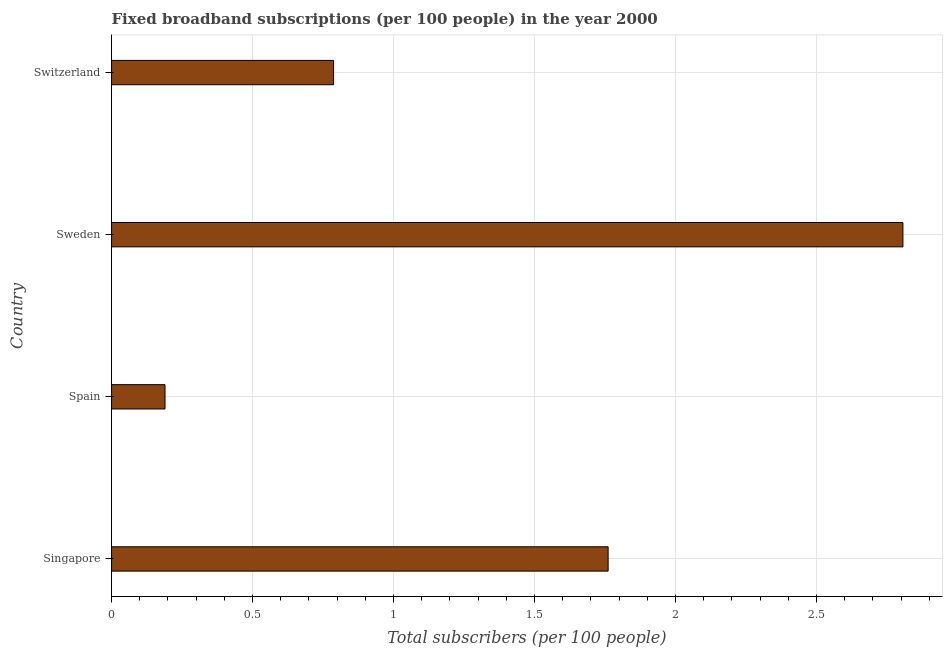What is the title of the graph?
Your response must be concise. Fixed broadband subscriptions (per 100 people) in the year 2000. What is the label or title of the X-axis?
Offer a very short reply. Total subscribers (per 100 people). What is the total number of fixed broadband subscriptions in Switzerland?
Your response must be concise. 0.79. Across all countries, what is the maximum total number of fixed broadband subscriptions?
Provide a succinct answer. 2.81. Across all countries, what is the minimum total number of fixed broadband subscriptions?
Your response must be concise. 0.19. What is the sum of the total number of fixed broadband subscriptions?
Ensure brevity in your answer.  5.54. What is the difference between the total number of fixed broadband subscriptions in Sweden and Switzerland?
Provide a succinct answer. 2.02. What is the average total number of fixed broadband subscriptions per country?
Make the answer very short. 1.39. What is the median total number of fixed broadband subscriptions?
Your response must be concise. 1.27. What is the ratio of the total number of fixed broadband subscriptions in Singapore to that in Switzerland?
Your answer should be very brief. 2.24. Is the difference between the total number of fixed broadband subscriptions in Sweden and Switzerland greater than the difference between any two countries?
Give a very brief answer. No. What is the difference between the highest and the second highest total number of fixed broadband subscriptions?
Your answer should be compact. 1.04. What is the difference between the highest and the lowest total number of fixed broadband subscriptions?
Keep it short and to the point. 2.62. In how many countries, is the total number of fixed broadband subscriptions greater than the average total number of fixed broadband subscriptions taken over all countries?
Keep it short and to the point. 2. How many bars are there?
Make the answer very short. 4. How many countries are there in the graph?
Provide a succinct answer. 4. Are the values on the major ticks of X-axis written in scientific E-notation?
Your answer should be compact. No. What is the Total subscribers (per 100 people) in Singapore?
Keep it short and to the point. 1.76. What is the Total subscribers (per 100 people) in Spain?
Give a very brief answer. 0.19. What is the Total subscribers (per 100 people) of Sweden?
Offer a terse response. 2.81. What is the Total subscribers (per 100 people) in Switzerland?
Give a very brief answer. 0.79. What is the difference between the Total subscribers (per 100 people) in Singapore and Spain?
Ensure brevity in your answer.  1.57. What is the difference between the Total subscribers (per 100 people) in Singapore and Sweden?
Provide a short and direct response. -1.05. What is the difference between the Total subscribers (per 100 people) in Singapore and Switzerland?
Offer a very short reply. 0.97. What is the difference between the Total subscribers (per 100 people) in Spain and Sweden?
Provide a short and direct response. -2.62. What is the difference between the Total subscribers (per 100 people) in Spain and Switzerland?
Your answer should be compact. -0.6. What is the difference between the Total subscribers (per 100 people) in Sweden and Switzerland?
Give a very brief answer. 2.02. What is the ratio of the Total subscribers (per 100 people) in Singapore to that in Spain?
Give a very brief answer. 9.29. What is the ratio of the Total subscribers (per 100 people) in Singapore to that in Sweden?
Your answer should be compact. 0.63. What is the ratio of the Total subscribers (per 100 people) in Singapore to that in Switzerland?
Offer a very short reply. 2.24. What is the ratio of the Total subscribers (per 100 people) in Spain to that in Sweden?
Give a very brief answer. 0.07. What is the ratio of the Total subscribers (per 100 people) in Spain to that in Switzerland?
Your answer should be very brief. 0.24. What is the ratio of the Total subscribers (per 100 people) in Sweden to that in Switzerland?
Offer a very short reply. 3.56. 